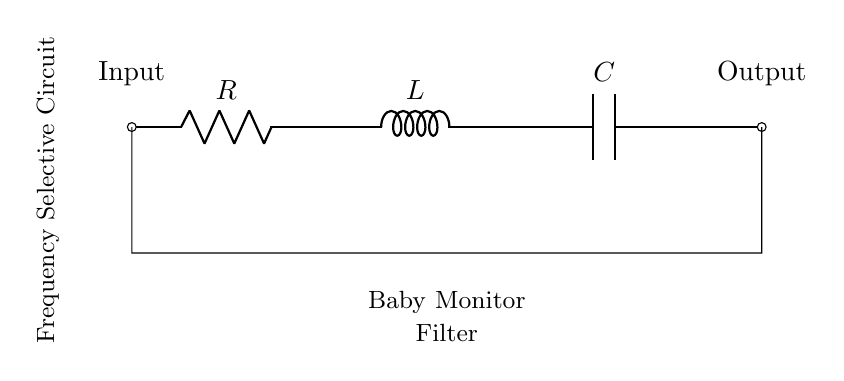What are the components in this circuit? The circuit consists of a resistor, an inductor, and a capacitor connected in series. Each component is represented in the diagram, with labels indicating their types.
Answer: Resistor, Inductor, Capacitor What is the function of this circuit? This circuit serves as a frequency selective circuit, often used to filter signals within a specific frequency range, which is useful in applications like a baby monitor. The labels and description in the circuit provide insight into its intended purpose.
Answer: Frequency selective circuit What type of circuit configuration is used here? The circuit configuration is a series arrangement, where the components are connected end-to-end. The schematic shows that the current flows through one component to the next in a single path.
Answer: Series What is the input to this circuit? The input is indicated at the left side of the circuit diagram where it connects to the resistor, which suggests that it receives the incoming signal to be filtered.
Answer: Input What is the output of this circuit? The output is shown at the right side of the diagram, where the final component, the capacitor, leads to the output terminal, indicating that filtered signals are delivered from this point.
Answer: Output Why is this circuit considered frequency selective? This circuit is frequency selective because it utilizes a combination of a resistor, inductor, and capacitor, which can create a specific resonant frequency. This configuration allows certain frequencies to pass through while attenuating others, which is essential for filtering signals effectively in applications such as a baby monitor.
Answer: It uses RLC for frequency selection 